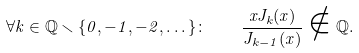Convert formula to latex. <formula><loc_0><loc_0><loc_500><loc_500>\forall k \in \mathbb { Q } \smallsetminus \{ 0 , - 1 , - 2 , \dots \} \colon \quad { \frac { x J _ { k } ( x ) } { J _ { k - 1 } ( x ) } } \notin \mathbb { Q } .</formula> 